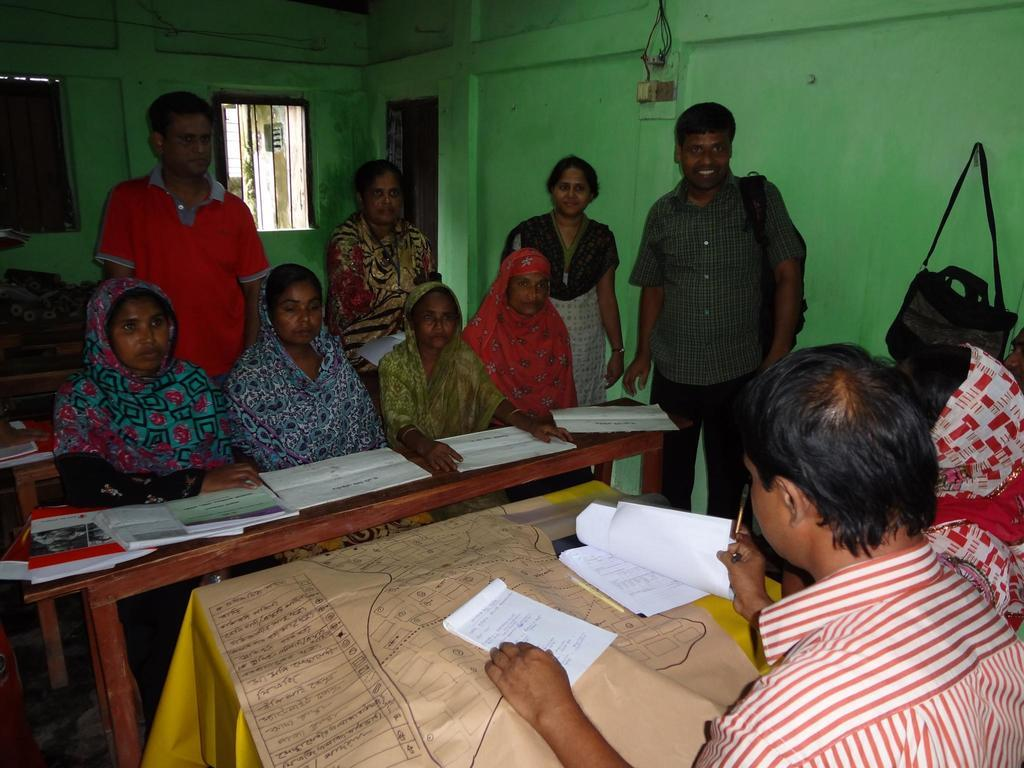What is the man on the right side of the image holding? The man is holding papers in his hands on the right side of the image. What are the women on the left side of the image doing? There are four women sitting on a bench on the left side of the image, and they are looking towards the right side of the image. What is the expression of the man on the left side of the image? The standing man on the left side of the image is smiling. What type of cherries are being combed by the man on the right side of the image? There are no cherries or combs present in the image. 